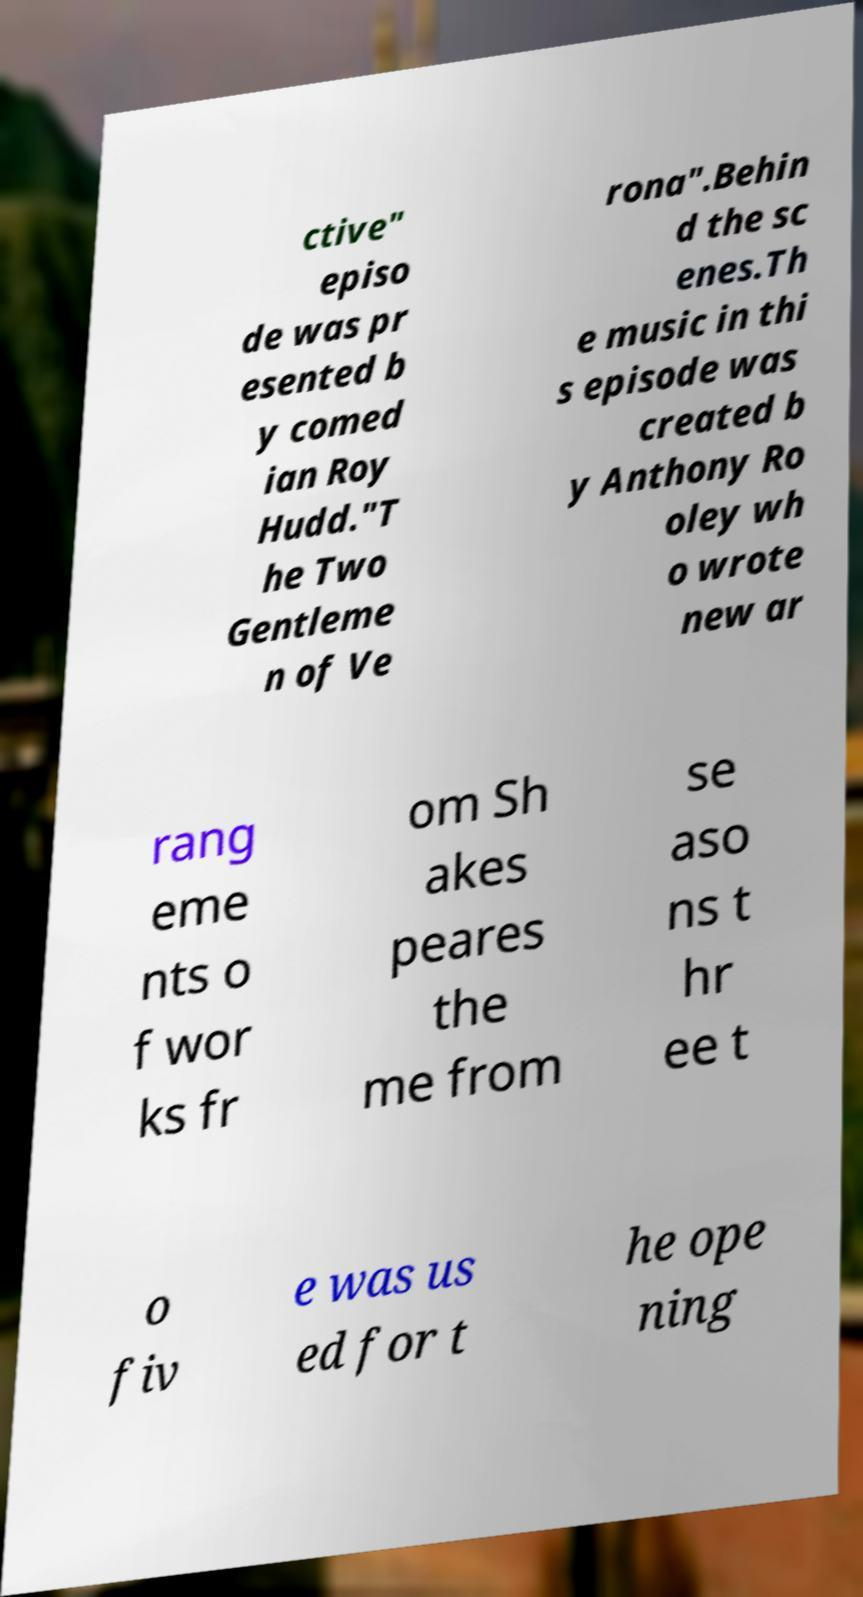I need the written content from this picture converted into text. Can you do that? ctive" episo de was pr esented b y comed ian Roy Hudd."T he Two Gentleme n of Ve rona".Behin d the sc enes.Th e music in thi s episode was created b y Anthony Ro oley wh o wrote new ar rang eme nts o f wor ks fr om Sh akes peares the me from se aso ns t hr ee t o fiv e was us ed for t he ope ning 